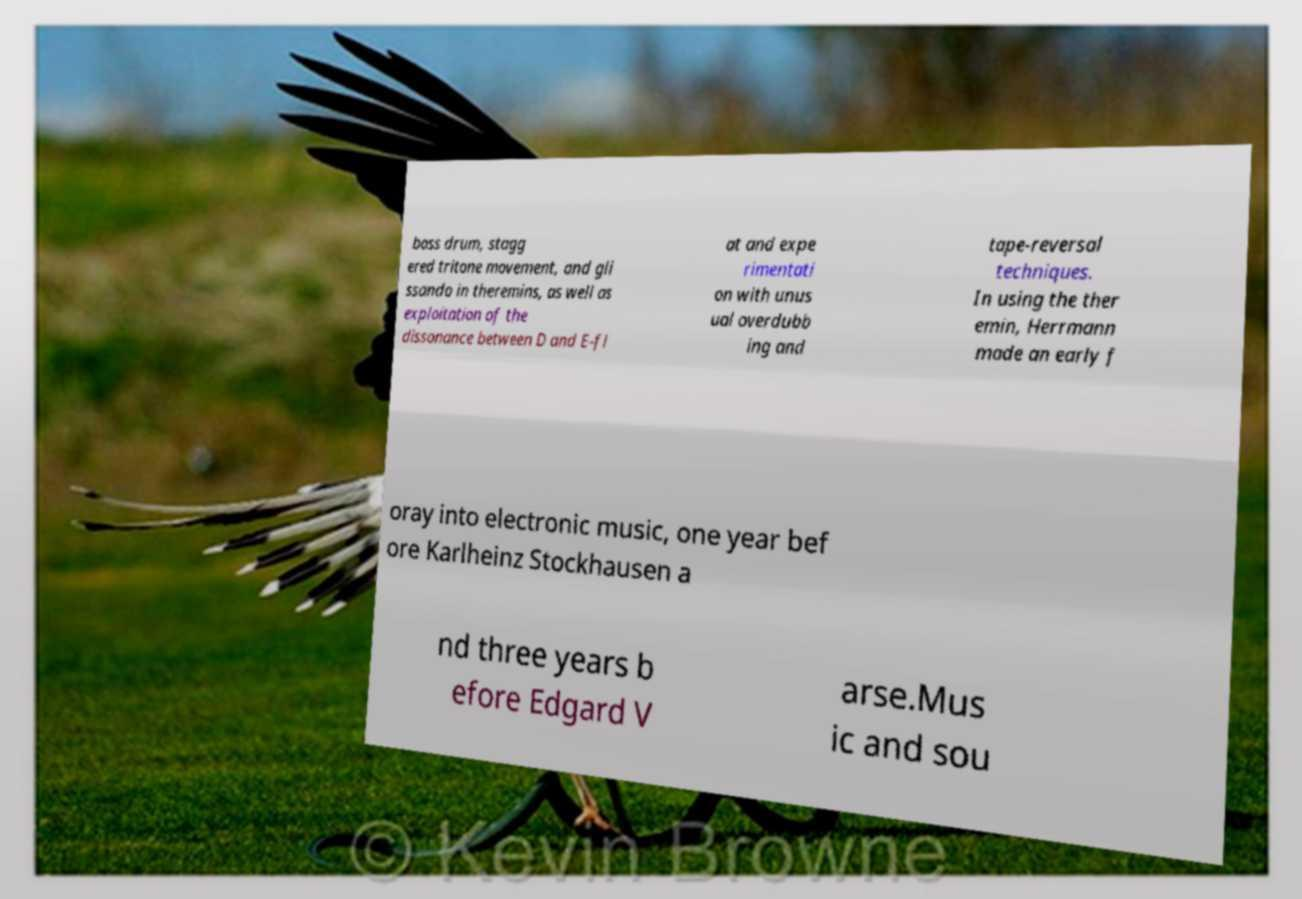I need the written content from this picture converted into text. Can you do that? bass drum, stagg ered tritone movement, and gli ssando in theremins, as well as exploitation of the dissonance between D and E-fl at and expe rimentati on with unus ual overdubb ing and tape-reversal techniques. In using the ther emin, Herrmann made an early f oray into electronic music, one year bef ore Karlheinz Stockhausen a nd three years b efore Edgard V arse.Mus ic and sou 